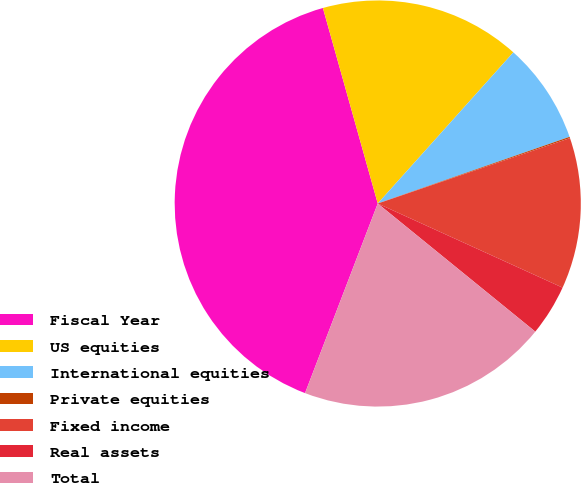<chart> <loc_0><loc_0><loc_500><loc_500><pie_chart><fcel>Fiscal Year<fcel>US equities<fcel>International equities<fcel>Private equities<fcel>Fixed income<fcel>Real assets<fcel>Total<nl><fcel>39.82%<fcel>15.99%<fcel>8.04%<fcel>0.1%<fcel>12.02%<fcel>4.07%<fcel>19.96%<nl></chart> 